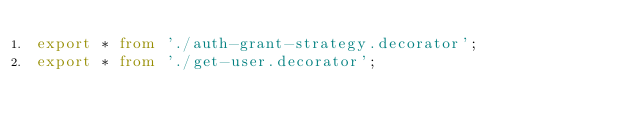<code> <loc_0><loc_0><loc_500><loc_500><_TypeScript_>export * from './auth-grant-strategy.decorator';
export * from './get-user.decorator';
</code> 